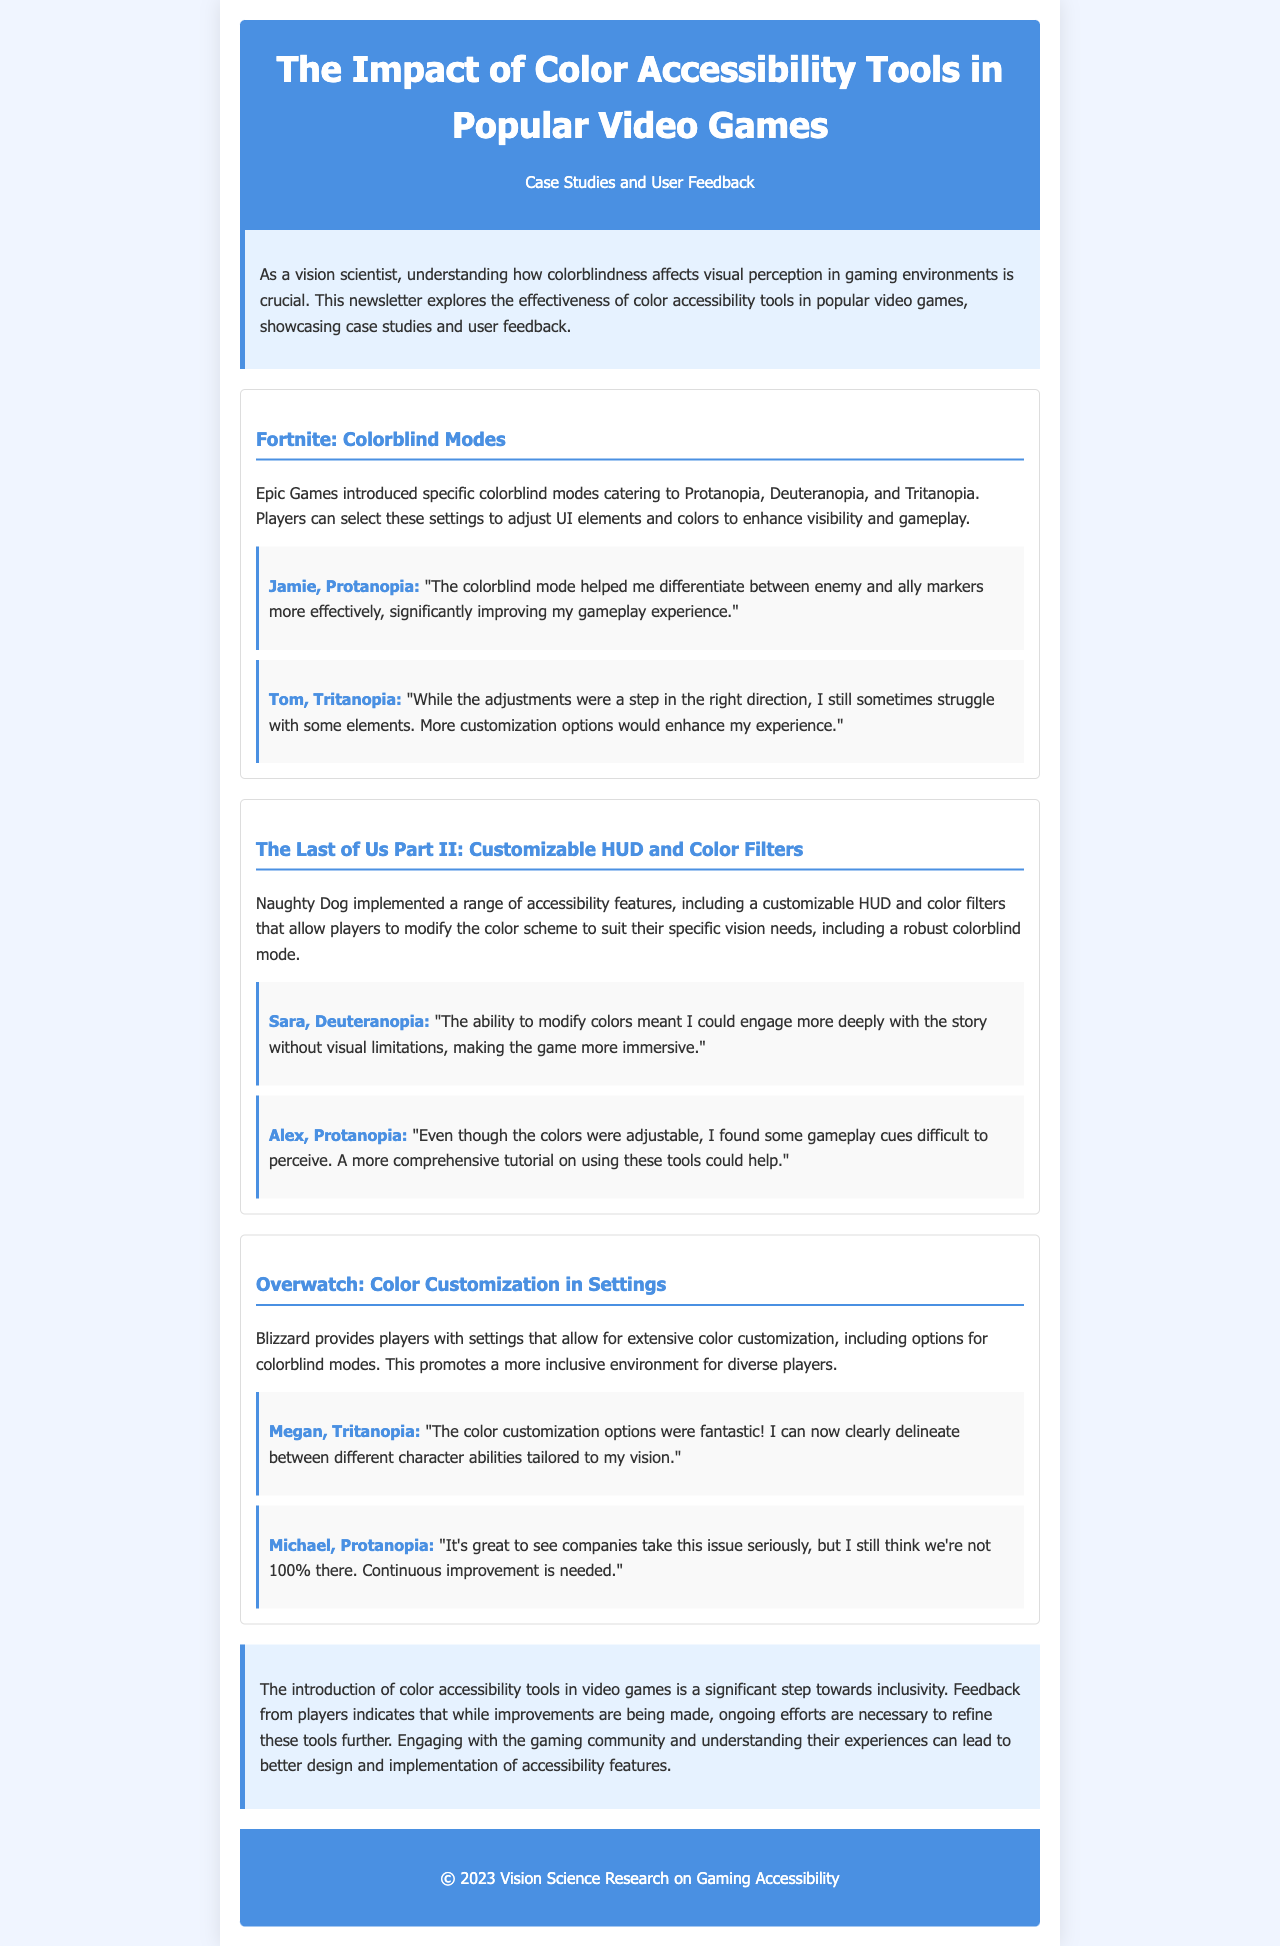What are the colorblind modes available in Fortnite? The document lists Protanopia, Deuteranopia, and Tritanopia as the available colorblind modes in Fortnite.
Answer: Protanopia, Deuteranopia, Tritanopia Who provided feedback about the colorblind mode in Fortnite? The feedback section included comments from Jamie and Tom regarding their experiences with the colorblind mode in Fortnite.
Answer: Jamie, Tom What feature does The Last of Us Part II offer for colorblind players? The document mentions a customizable HUD and color filters as features for colorblind players in The Last of Us Part II.
Answer: Customizable HUD and color filters Which game introduced extensive color customization options for players? The section on Overwatch describes the extensive color customization options available for players.
Answer: Overwatch What was Sara's experience with color accessibility in The Last of Us Part II? Sara noted that modifying colors allowed her to engage more deeply with the story, highlighting the impact on immersion.
Answer: More immersive engagement with the story What does the conclusion suggest is necessary for color accessibility tools? The conclusion emphasizes the need for ongoing efforts to refine color accessibility tools in video games.
Answer: Ongoing efforts are necessary How did Megan describe the color customization options in Overwatch? Megan expressed that the color customization options were fantastic and improved her ability to differentiate between character abilities.
Answer: Fantastic What does the newsletter primarily focus on? The newsletter focuses on the effectiveness of color accessibility tools in popular video games and includes case studies and user feedback.
Answer: Effectiveness of color accessibility tools 